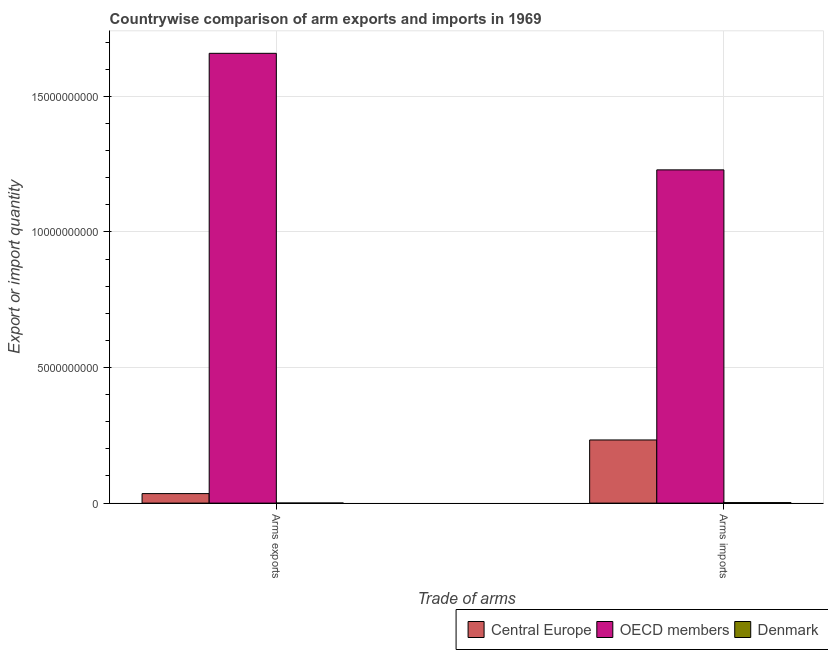How many different coloured bars are there?
Provide a short and direct response. 3. How many groups of bars are there?
Provide a short and direct response. 2. Are the number of bars per tick equal to the number of legend labels?
Give a very brief answer. Yes. How many bars are there on the 2nd tick from the right?
Offer a terse response. 3. What is the label of the 1st group of bars from the left?
Offer a very short reply. Arms exports. What is the arms exports in OECD members?
Provide a short and direct response. 1.66e+1. Across all countries, what is the maximum arms exports?
Make the answer very short. 1.66e+1. Across all countries, what is the minimum arms exports?
Offer a terse response. 3.00e+06. In which country was the arms imports maximum?
Your answer should be compact. OECD members. In which country was the arms exports minimum?
Your answer should be compact. Denmark. What is the total arms exports in the graph?
Your answer should be very brief. 1.69e+1. What is the difference between the arms exports in Denmark and that in OECD members?
Your answer should be compact. -1.66e+1. What is the difference between the arms exports in Central Europe and the arms imports in Denmark?
Offer a very short reply. 3.32e+08. What is the average arms exports per country?
Offer a very short reply. 5.65e+09. What is the difference between the arms exports and arms imports in Central Europe?
Ensure brevity in your answer.  -1.98e+09. In how many countries, is the arms imports greater than 12000000000 ?
Give a very brief answer. 1. What is the ratio of the arms imports in Central Europe to that in Denmark?
Offer a terse response. 122.58. Is the arms exports in OECD members less than that in Denmark?
Provide a succinct answer. No. In how many countries, is the arms imports greater than the average arms imports taken over all countries?
Your response must be concise. 1. What does the 1st bar from the left in Arms imports represents?
Offer a terse response. Central Europe. How many bars are there?
Offer a very short reply. 6. Are all the bars in the graph horizontal?
Make the answer very short. No. What is the difference between two consecutive major ticks on the Y-axis?
Offer a very short reply. 5.00e+09. Are the values on the major ticks of Y-axis written in scientific E-notation?
Offer a very short reply. No. Does the graph contain any zero values?
Ensure brevity in your answer.  No. Does the graph contain grids?
Offer a terse response. Yes. Where does the legend appear in the graph?
Your answer should be very brief. Bottom right. How are the legend labels stacked?
Keep it short and to the point. Horizontal. What is the title of the graph?
Your response must be concise. Countrywise comparison of arm exports and imports in 1969. What is the label or title of the X-axis?
Your answer should be very brief. Trade of arms. What is the label or title of the Y-axis?
Offer a terse response. Export or import quantity. What is the Export or import quantity of Central Europe in Arms exports?
Make the answer very short. 3.51e+08. What is the Export or import quantity in OECD members in Arms exports?
Offer a terse response. 1.66e+1. What is the Export or import quantity of Central Europe in Arms imports?
Your answer should be very brief. 2.33e+09. What is the Export or import quantity of OECD members in Arms imports?
Ensure brevity in your answer.  1.23e+1. What is the Export or import quantity of Denmark in Arms imports?
Your answer should be very brief. 1.90e+07. Across all Trade of arms, what is the maximum Export or import quantity of Central Europe?
Your answer should be compact. 2.33e+09. Across all Trade of arms, what is the maximum Export or import quantity in OECD members?
Provide a short and direct response. 1.66e+1. Across all Trade of arms, what is the maximum Export or import quantity of Denmark?
Your response must be concise. 1.90e+07. Across all Trade of arms, what is the minimum Export or import quantity of Central Europe?
Your answer should be compact. 3.51e+08. Across all Trade of arms, what is the minimum Export or import quantity in OECD members?
Ensure brevity in your answer.  1.23e+1. Across all Trade of arms, what is the minimum Export or import quantity in Denmark?
Provide a short and direct response. 3.00e+06. What is the total Export or import quantity in Central Europe in the graph?
Give a very brief answer. 2.68e+09. What is the total Export or import quantity in OECD members in the graph?
Keep it short and to the point. 2.89e+1. What is the total Export or import quantity in Denmark in the graph?
Give a very brief answer. 2.20e+07. What is the difference between the Export or import quantity in Central Europe in Arms exports and that in Arms imports?
Ensure brevity in your answer.  -1.98e+09. What is the difference between the Export or import quantity in OECD members in Arms exports and that in Arms imports?
Provide a short and direct response. 4.30e+09. What is the difference between the Export or import quantity in Denmark in Arms exports and that in Arms imports?
Provide a short and direct response. -1.60e+07. What is the difference between the Export or import quantity of Central Europe in Arms exports and the Export or import quantity of OECD members in Arms imports?
Give a very brief answer. -1.19e+1. What is the difference between the Export or import quantity in Central Europe in Arms exports and the Export or import quantity in Denmark in Arms imports?
Provide a short and direct response. 3.32e+08. What is the difference between the Export or import quantity in OECD members in Arms exports and the Export or import quantity in Denmark in Arms imports?
Ensure brevity in your answer.  1.66e+1. What is the average Export or import quantity in Central Europe per Trade of arms?
Keep it short and to the point. 1.34e+09. What is the average Export or import quantity in OECD members per Trade of arms?
Provide a succinct answer. 1.44e+1. What is the average Export or import quantity in Denmark per Trade of arms?
Your answer should be very brief. 1.10e+07. What is the difference between the Export or import quantity in Central Europe and Export or import quantity in OECD members in Arms exports?
Ensure brevity in your answer.  -1.62e+1. What is the difference between the Export or import quantity of Central Europe and Export or import quantity of Denmark in Arms exports?
Keep it short and to the point. 3.48e+08. What is the difference between the Export or import quantity in OECD members and Export or import quantity in Denmark in Arms exports?
Keep it short and to the point. 1.66e+1. What is the difference between the Export or import quantity of Central Europe and Export or import quantity of OECD members in Arms imports?
Provide a short and direct response. -9.96e+09. What is the difference between the Export or import quantity in Central Europe and Export or import quantity in Denmark in Arms imports?
Your answer should be very brief. 2.31e+09. What is the difference between the Export or import quantity of OECD members and Export or import quantity of Denmark in Arms imports?
Offer a very short reply. 1.23e+1. What is the ratio of the Export or import quantity of Central Europe in Arms exports to that in Arms imports?
Give a very brief answer. 0.15. What is the ratio of the Export or import quantity in OECD members in Arms exports to that in Arms imports?
Offer a terse response. 1.35. What is the ratio of the Export or import quantity in Denmark in Arms exports to that in Arms imports?
Keep it short and to the point. 0.16. What is the difference between the highest and the second highest Export or import quantity in Central Europe?
Your answer should be compact. 1.98e+09. What is the difference between the highest and the second highest Export or import quantity of OECD members?
Ensure brevity in your answer.  4.30e+09. What is the difference between the highest and the second highest Export or import quantity in Denmark?
Your answer should be very brief. 1.60e+07. What is the difference between the highest and the lowest Export or import quantity of Central Europe?
Your response must be concise. 1.98e+09. What is the difference between the highest and the lowest Export or import quantity in OECD members?
Ensure brevity in your answer.  4.30e+09. What is the difference between the highest and the lowest Export or import quantity in Denmark?
Make the answer very short. 1.60e+07. 